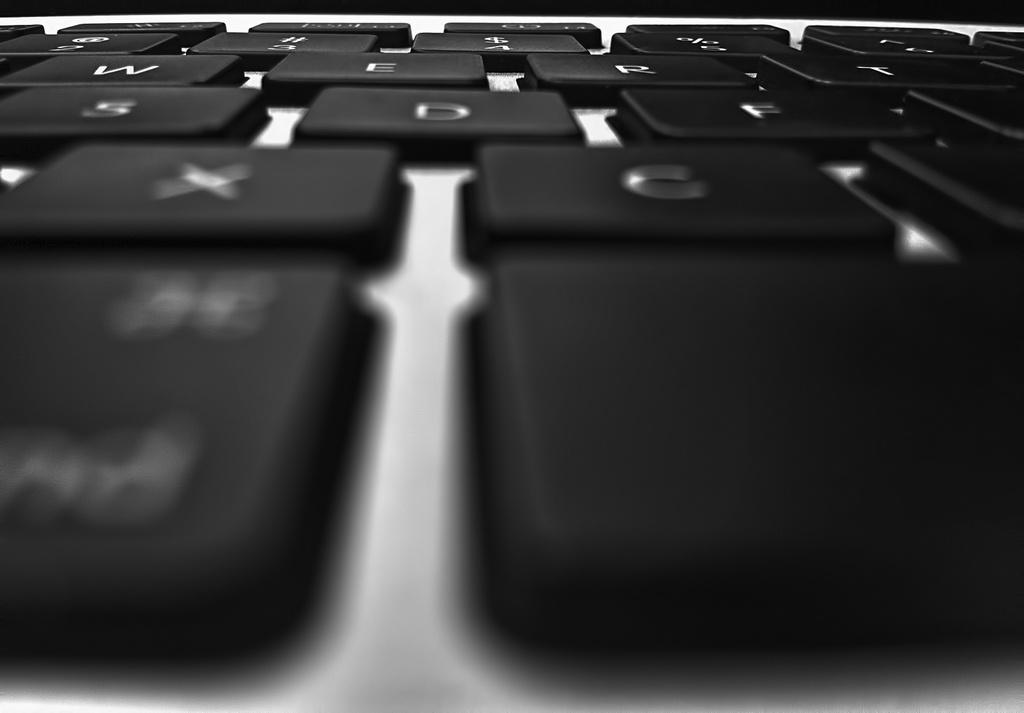What objects are visible in the image? There are keys of a keyboard in the image. Can you describe the keys in more detail? The keys are likely arranged in a standard layout, with letters, numbers, and symbols on them. What might someone be doing with the keyboard? Someone might be typing on the keyboard, playing a musical instrument, or using it for another purpose. How many trees can be seen in the image? There are no trees visible in the image; it only features keys of a keyboard. 